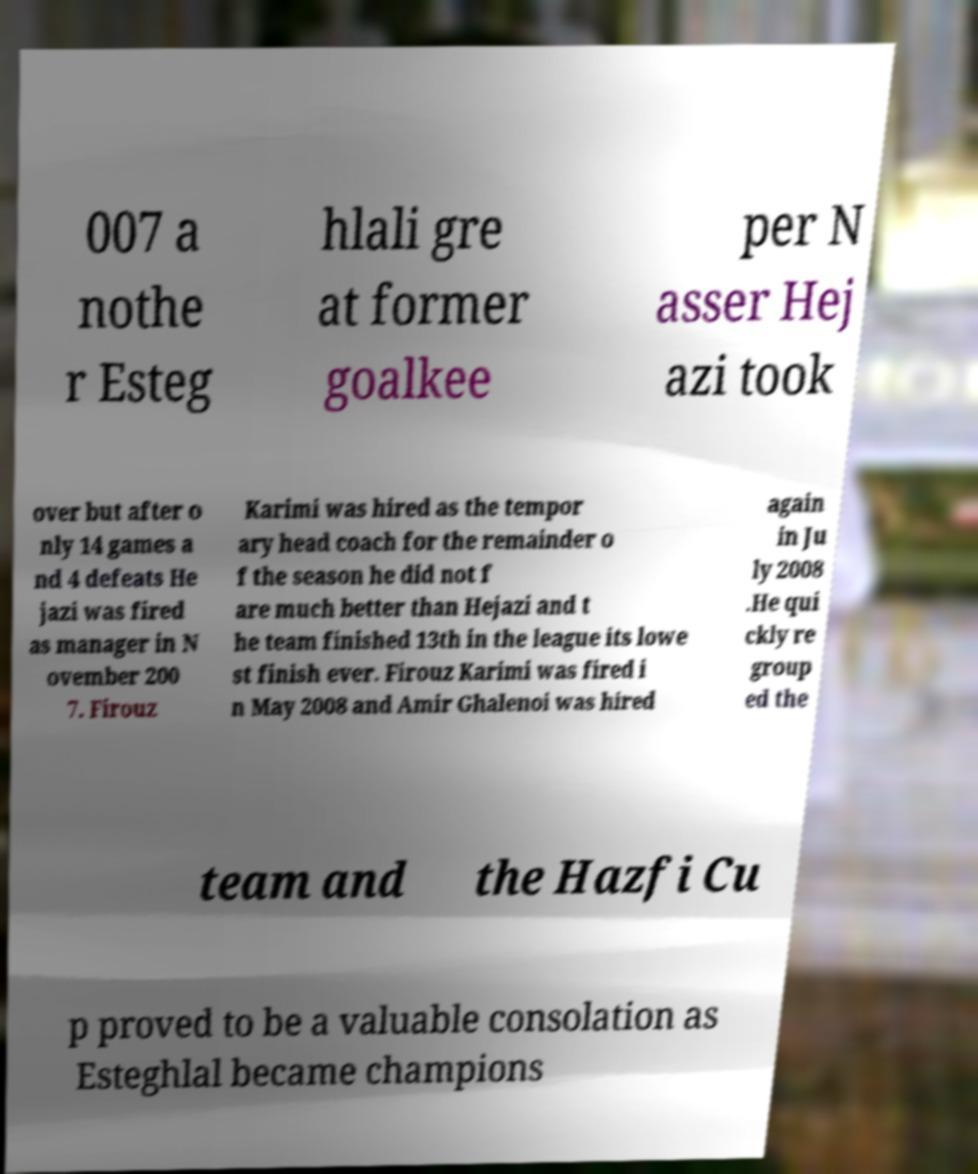Please identify and transcribe the text found in this image. 007 a nothe r Esteg hlali gre at former goalkee per N asser Hej azi took over but after o nly 14 games a nd 4 defeats He jazi was fired as manager in N ovember 200 7. Firouz Karimi was hired as the tempor ary head coach for the remainder o f the season he did not f are much better than Hejazi and t he team finished 13th in the league its lowe st finish ever. Firouz Karimi was fired i n May 2008 and Amir Ghalenoi was hired again in Ju ly 2008 .He qui ckly re group ed the team and the Hazfi Cu p proved to be a valuable consolation as Esteghlal became champions 